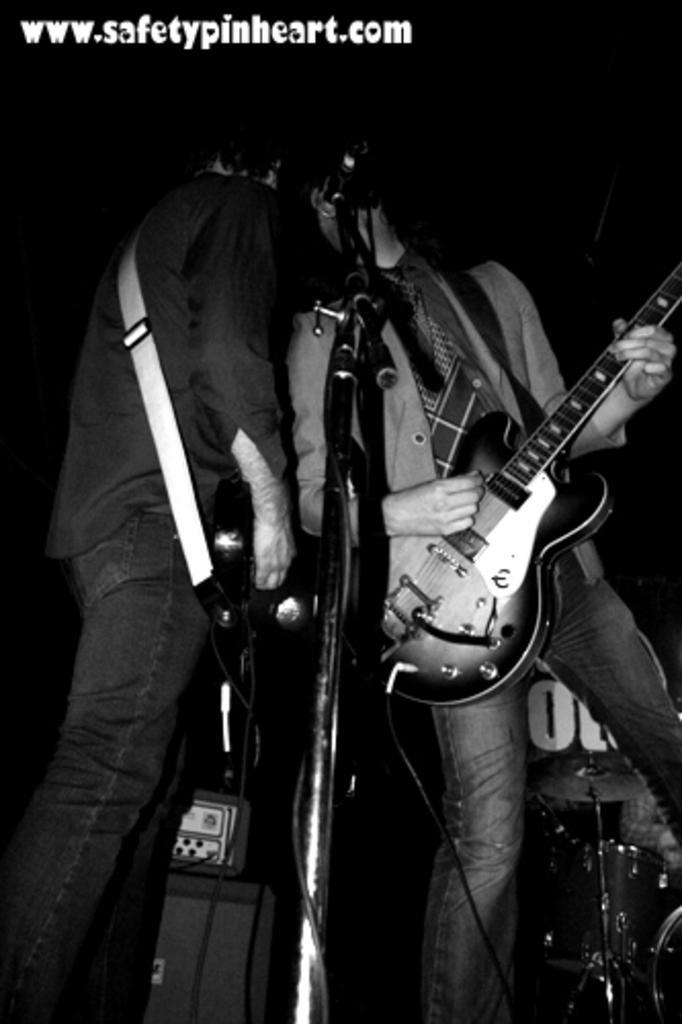Can you describe this image briefly? This is a black and white picture. Here we can see two persons are playing guitar. This is mike and there are some musical instruments. 